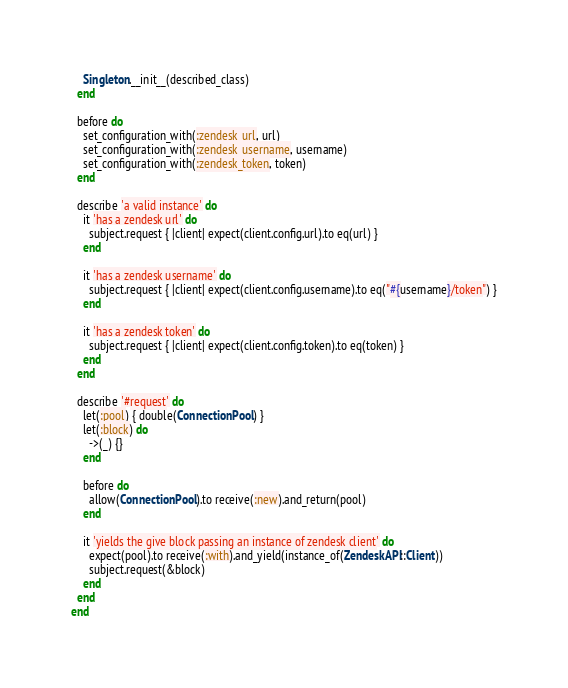Convert code to text. <code><loc_0><loc_0><loc_500><loc_500><_Ruby_>    Singleton.__init__(described_class)
  end

  before do
    set_configuration_with(:zendesk_url, url)
    set_configuration_with(:zendesk_username, username)
    set_configuration_with(:zendesk_token, token)
  end

  describe 'a valid instance' do
    it 'has a zendesk url' do
      subject.request { |client| expect(client.config.url).to eq(url) }
    end

    it 'has a zendesk username' do
      subject.request { |client| expect(client.config.username).to eq("#{username}/token") }
    end

    it 'has a zendesk token' do
      subject.request { |client| expect(client.config.token).to eq(token) }
    end
  end

  describe '#request' do
    let(:pool) { double(ConnectionPool) }
    let(:block) do
      ->(_) {}
    end

    before do
      allow(ConnectionPool).to receive(:new).and_return(pool)
    end

    it 'yields the give block passing an instance of zendesk client' do
      expect(pool).to receive(:with).and_yield(instance_of(ZendeskAPI::Client))
      subject.request(&block)
    end
  end
end
</code> 